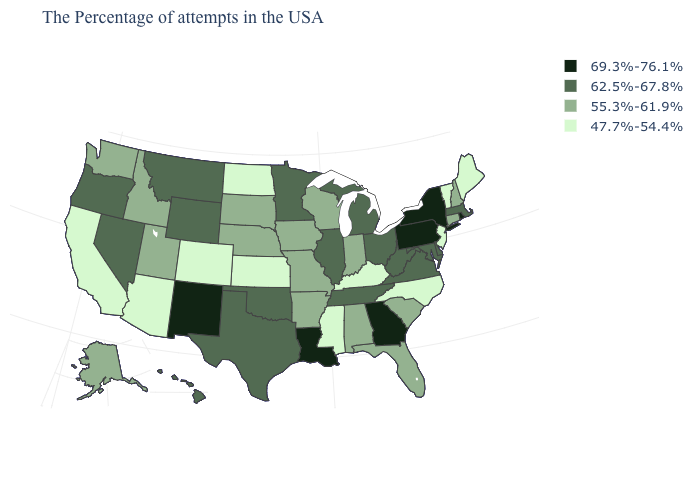Name the states that have a value in the range 55.3%-61.9%?
Keep it brief. New Hampshire, Connecticut, South Carolina, Florida, Indiana, Alabama, Wisconsin, Missouri, Arkansas, Iowa, Nebraska, South Dakota, Utah, Idaho, Washington, Alaska. What is the value of Utah?
Concise answer only. 55.3%-61.9%. Name the states that have a value in the range 55.3%-61.9%?
Write a very short answer. New Hampshire, Connecticut, South Carolina, Florida, Indiana, Alabama, Wisconsin, Missouri, Arkansas, Iowa, Nebraska, South Dakota, Utah, Idaho, Washington, Alaska. What is the highest value in the USA?
Quick response, please. 69.3%-76.1%. Does the first symbol in the legend represent the smallest category?
Write a very short answer. No. What is the value of South Carolina?
Write a very short answer. 55.3%-61.9%. Does Idaho have a lower value than Michigan?
Write a very short answer. Yes. Name the states that have a value in the range 47.7%-54.4%?
Give a very brief answer. Maine, Vermont, New Jersey, North Carolina, Kentucky, Mississippi, Kansas, North Dakota, Colorado, Arizona, California. Name the states that have a value in the range 62.5%-67.8%?
Short answer required. Massachusetts, Delaware, Maryland, Virginia, West Virginia, Ohio, Michigan, Tennessee, Illinois, Minnesota, Oklahoma, Texas, Wyoming, Montana, Nevada, Oregon, Hawaii. Name the states that have a value in the range 69.3%-76.1%?
Quick response, please. Rhode Island, New York, Pennsylvania, Georgia, Louisiana, New Mexico. What is the value of Ohio?
Quick response, please. 62.5%-67.8%. What is the value of Alabama?
Write a very short answer. 55.3%-61.9%. Does New Mexico have the same value as Nebraska?
Quick response, please. No. What is the highest value in states that border Idaho?
Give a very brief answer. 62.5%-67.8%. What is the highest value in the USA?
Short answer required. 69.3%-76.1%. 